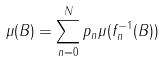Convert formula to latex. <formula><loc_0><loc_0><loc_500><loc_500>\mu ( B ) = \sum _ { n = 0 } ^ { N } p _ { n } \mu ( f _ { n } ^ { - 1 } ( B ) )</formula> 